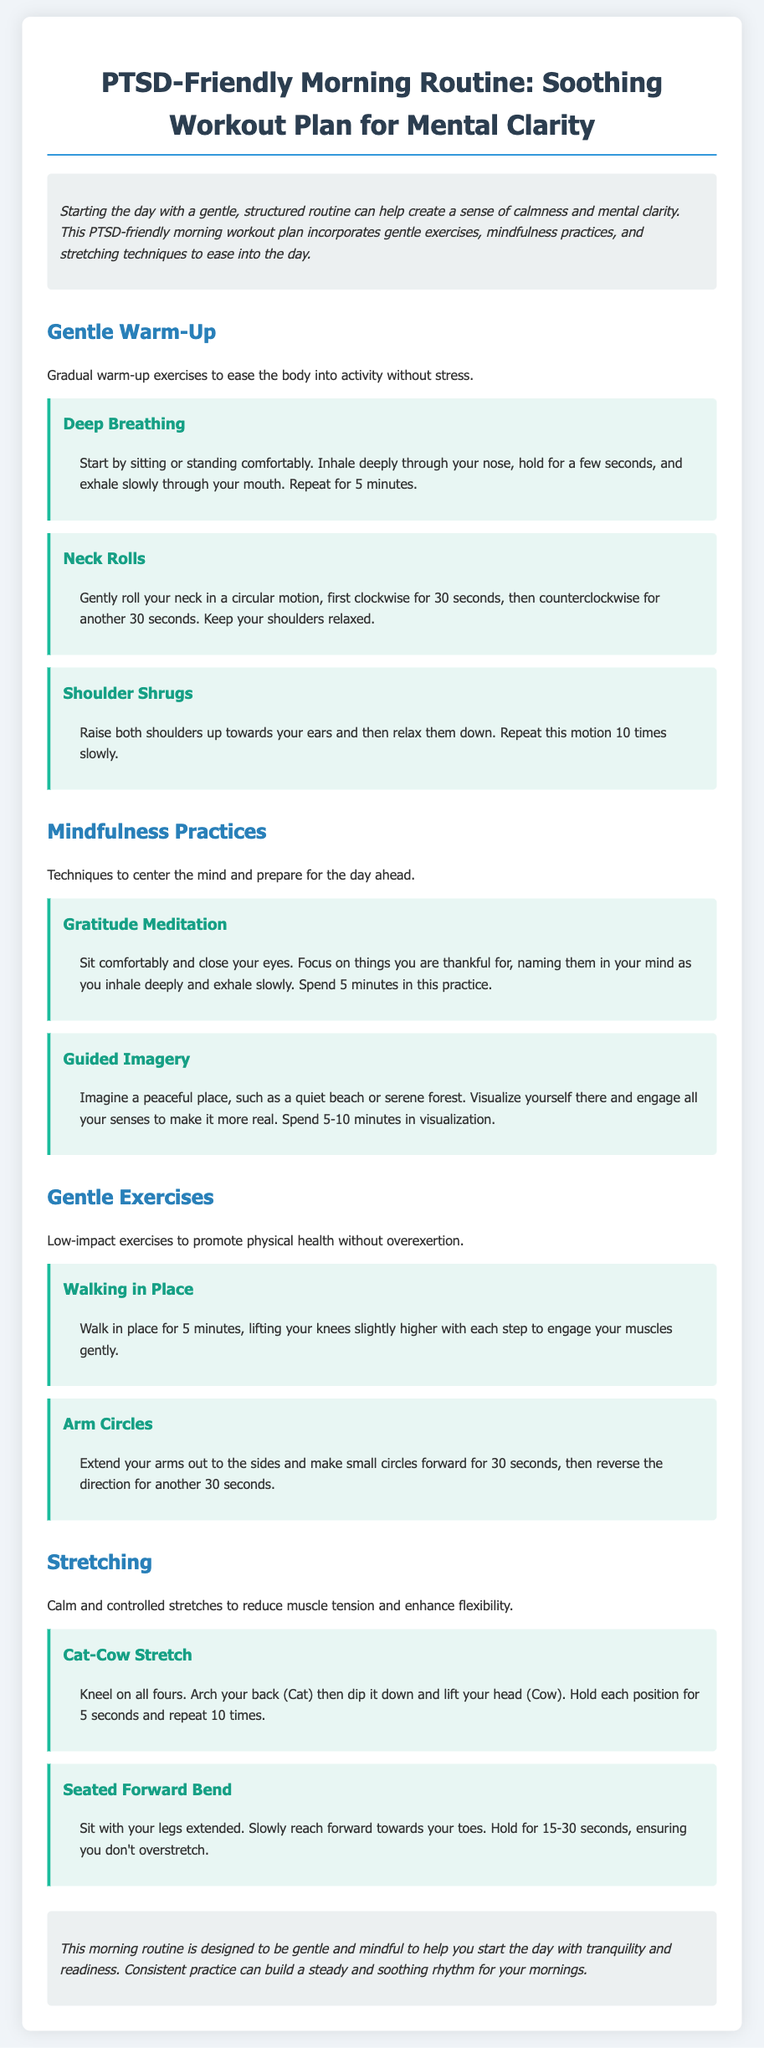What is the title of the document? The title of the document is presented in the main heading, which outlines the topic of the morning routine designed for PTSD.
Answer: PTSD-Friendly Morning Routine: Soothing Workout Plan for Mental Clarity How many minutes should you spend on Gratitude Meditation? The document specifies that the practice should last for a certain duration to achieve its benefits.
Answer: 5 minutes What is the first exercise listed in the Gentle Warm-Up section? The first exercise is highlighted in the section focusing on warm-up activities suitable for easing tension.
Answer: Deep Breathing What is the duration recommended for Walking in Place? The document provides a specific time frame for this low-impact exercise to ensure it is manageable.
Answer: 5 minutes How many times should you repeat the Cat-Cow Stretch? The appropriate number of repetitions for the stretch is given in the instructions to encourage effective stretching.
Answer: 10 times What type of practice is Guided Imagery considered? The document categorizes this activity under a specific type aimed at mental centering.
Answer: Mindfulness Practice What do you do during the Seated Forward Bend? The instructions detail the action required to effectively perform this stretching exercise.
Answer: Reach forward towards your toes What overall benefit does this morning routine aim to provide? The introduction of the document summarizes the primary goal of the routine.
Answer: Tranquility and readiness 